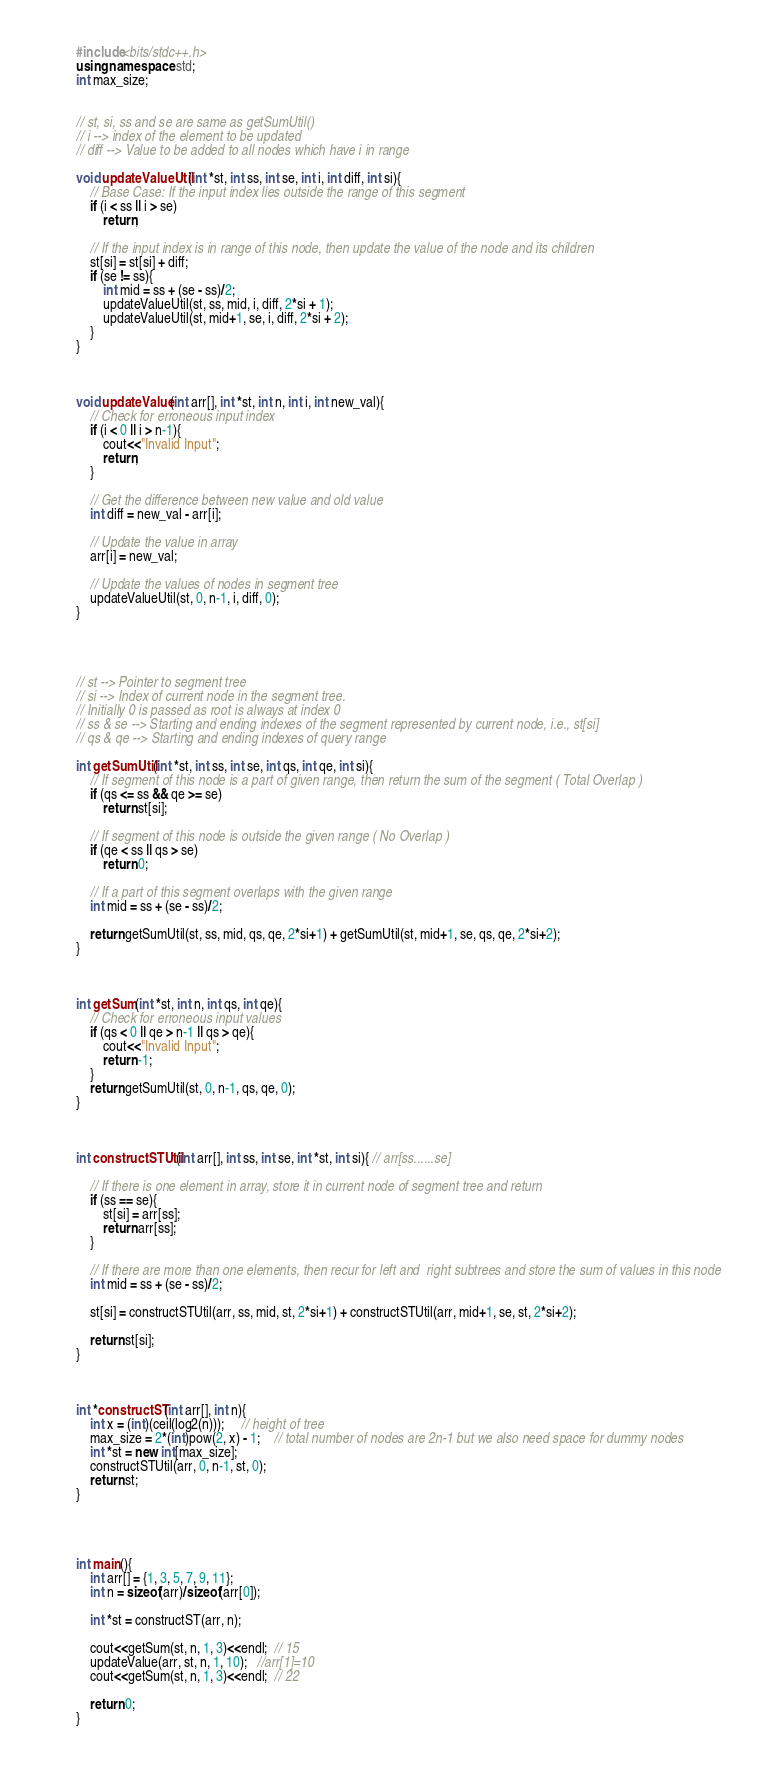Convert code to text. <code><loc_0><loc_0><loc_500><loc_500><_C++_>#include<bits/stdc++.h>
using namespace std;
int max_size;


// st, si, ss and se are same as getSumUtil()
// i --> index of the element to be updated
// diff --> Value to be added to all nodes which have i in range

void updateValueUtil(int *st, int ss, int se, int i, int diff, int si){
	// Base Case: If the input index lies outside the range of this segment
	if (i < ss || i > se)
		return;

	// If the input index is in range of this node, then update the value of the node and its children
	st[si] = st[si] + diff;
	if (se != ss){
		int mid = ss + (se - ss)/2;
		updateValueUtil(st, ss, mid, i, diff, 2*si + 1);
		updateValueUtil(st, mid+1, se, i, diff, 2*si + 2);
	}
}



void updateValue(int arr[], int *st, int n, int i, int new_val){
	// Check for erroneous input index
	if (i < 0 || i > n-1){
		cout<<"Invalid Input";
		return;
	}

	// Get the difference between new value and old value
	int diff = new_val - arr[i];

	// Update the value in array
	arr[i] = new_val;

	// Update the values of nodes in segment tree
	updateValueUtil(st, 0, n-1, i, diff, 0);
}




// st --> Pointer to segment tree
// si --> Index of current node in the segment tree.
// Initially 0 is passed as root is always at index 0
// ss & se --> Starting and ending indexes of the segment represented by current node, i.e., st[si]
// qs & qe --> Starting and ending indexes of query range

int getSumUtil(int *st, int ss, int se, int qs, int qe, int si){
	// If segment of this node is a part of given range, then return the sum of the segment ( Total Overlap )
	if (qs <= ss && qe >= se)
		return st[si];

	// If segment of this node is outside the given range ( No Overlap )
	if (qe < ss || qs > se)
		return 0;

	// If a part of this segment overlaps with the given range
	int mid = ss + (se - ss)/2;

	return getSumUtil(st, ss, mid, qs, qe, 2*si+1) + getSumUtil(st, mid+1, se, qs, qe, 2*si+2);
}



int getSum(int *st, int n, int qs, int qe){
	// Check for erroneous input values
	if (qs < 0 || qe > n-1 || qs > qe){
		cout<<"Invalid Input";
		return -1;
	}
	return getSumUtil(st, 0, n-1, qs, qe, 0);
}



int constructSTUtil(int arr[], int ss, int se, int *st, int si){ // arr[ss......se]

    // If there is one element in array, store it in current node of segment tree and return
    if (ss == se){
		st[si] = arr[ss];
		return arr[ss];
	}

	// If there are more than one elements, then recur for left and  right subtrees and store the sum of values in this node
	int mid = ss + (se - ss)/2;

	st[si] = constructSTUtil(arr, ss, mid, st, 2*si+1) + constructSTUtil(arr, mid+1, se, st, 2*si+2);

	return st[si];
}



int *constructST(int arr[], int n){
    int x = (int)(ceil(log2(n)));     // height of tree
    max_size = 2*(int)pow(2, x) - 1;    // total number of nodes are 2n-1 but we also need space for dummy nodes
    int *st = new int[max_size];
    constructSTUtil(arr, 0, n-1, st, 0);
    return st;
}




int main(){
    int arr[] = {1, 3, 5, 7, 9, 11};
	int n = sizeof(arr)/sizeof(arr[0]);

	int *st = constructST(arr, n);

	cout<<getSum(st, n, 1, 3)<<endl;  // 15
	updateValue(arr, st, n, 1, 10);   //arr[1]=10
	cout<<getSum(st, n, 1, 3)<<endl;  // 22

    return 0;
}
</code> 